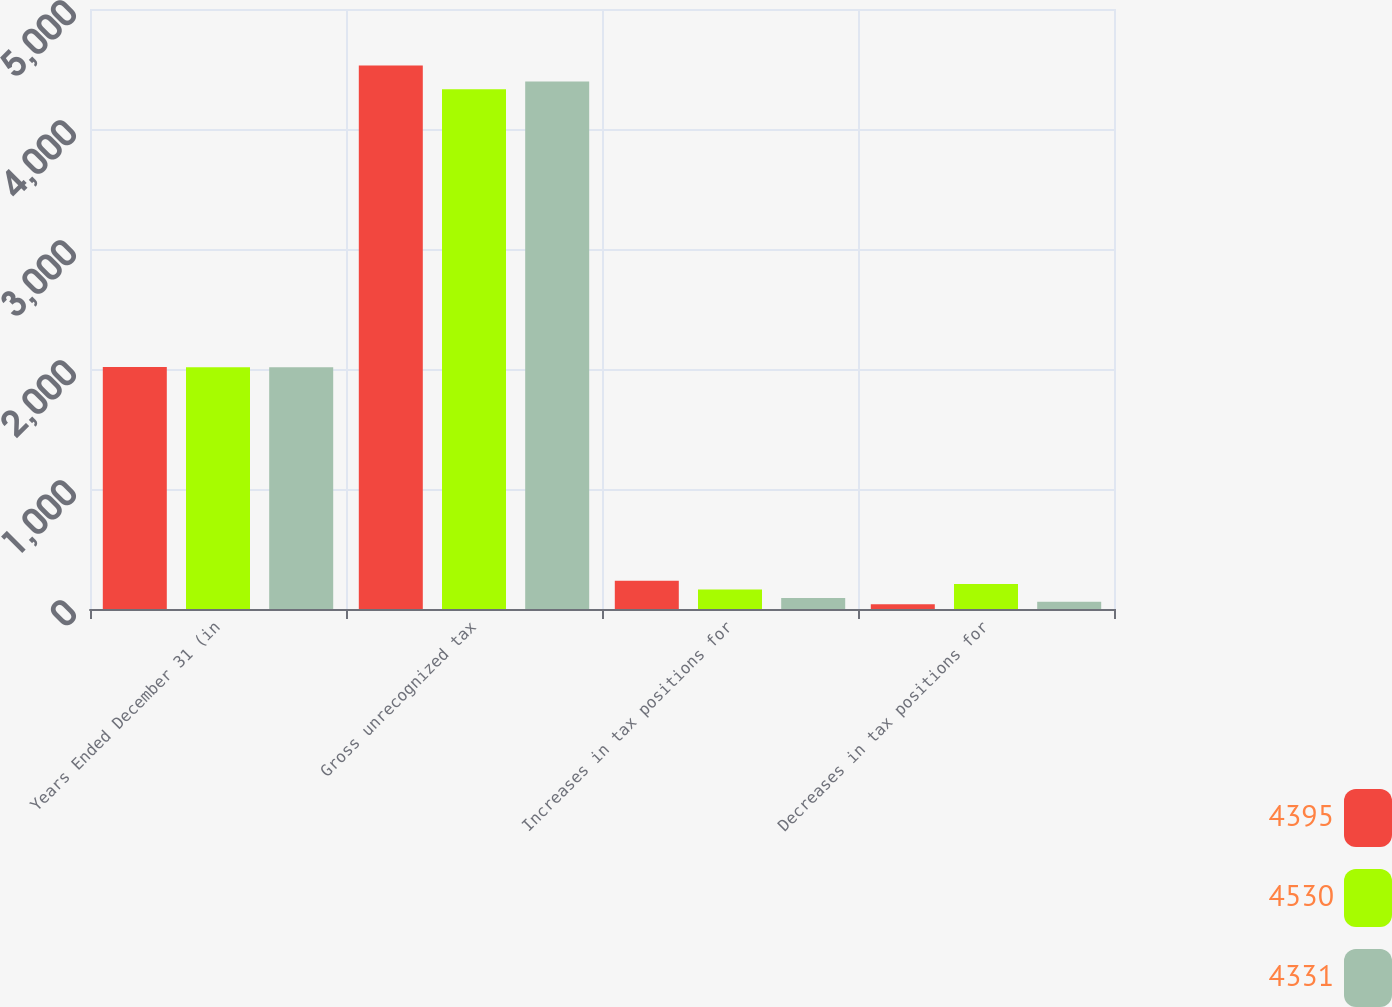Convert chart. <chart><loc_0><loc_0><loc_500><loc_500><stacked_bar_chart><ecel><fcel>Years Ended December 31 (in<fcel>Gross unrecognized tax<fcel>Increases in tax positions for<fcel>Decreases in tax positions for<nl><fcel>4395<fcel>2016<fcel>4530<fcel>235<fcel>39<nl><fcel>4530<fcel>2015<fcel>4331<fcel>162<fcel>209<nl><fcel>4331<fcel>2014<fcel>4395<fcel>91<fcel>60<nl></chart> 